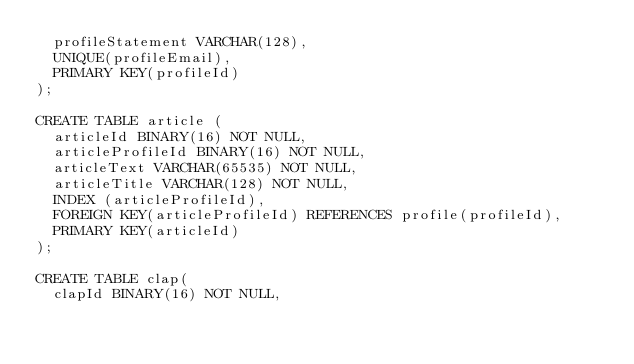Convert code to text. <code><loc_0><loc_0><loc_500><loc_500><_SQL_>  profileStatement VARCHAR(128),
  UNIQUE(profileEmail),
  PRIMARY KEY(profileId)
);

CREATE TABLE article (
  articleId BINARY(16) NOT NULL,
  articleProfileId BINARY(16) NOT NULL,
  articleText VARCHAR(65535) NOT NULL,
  articleTitle VARCHAR(128) NOT NULL,
  INDEX (articleProfileId),
  FOREIGN KEY(articleProfileId) REFERENCES profile(profileId),
  PRIMARY KEY(articleId)
);

CREATE TABLE clap(
  clapId BINARY(16) NOT NULL,</code> 